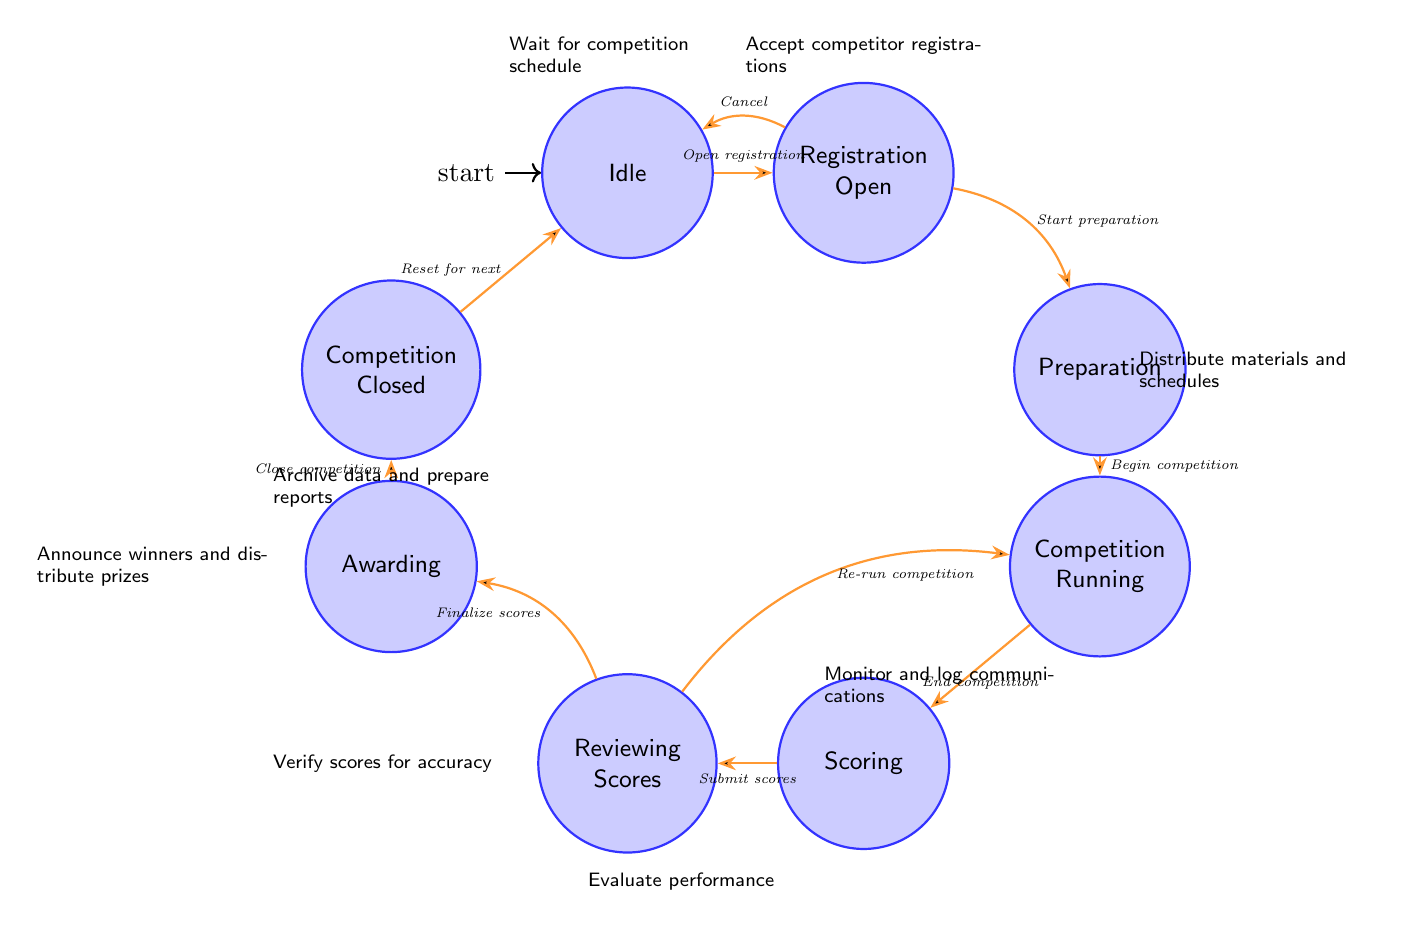What is the initial state of the competition workflow? The initial state is represented by the node labeled "Idle," which indicates that the system is waiting for competition scheduling before moving on.
Answer: Idle How many states are there in total? The diagram lists eight distinct states: Idle, Registration Open, Preparation, Competition Running, Scoring, Reviewing Scores, Awarding, and Competition Closed, which sum up to eight.
Answer: Eight What action follows the state "Scoring"? After the "Scoring" state, the diagram indicates the next state is "Reviewing Scores," as shown by the directed transition arrow leading to it.
Answer: Reviewing Scores What transition happens after "Competition Closed"? The "Competition Closed" state transitions back to "Idle," indicating that the workflow resets after concluding a competition.
Answer: Idle What happens in the "Registration Open" state? In the "Registration Open" state, the workflow involves accepting registrations from competitors as stated in the actions associated with this state.
Answer: Accept competitor registrations What is the final action taken before the competition is closed? The action that takes place right before closing the competition is "Announce winners and distribute prizes," which occurs in the "Awarding" state.
Answer: Announce winners and distribute prizes If a competition is running, what is the next state after scoring? Once scoring is completed in the "Scoring" state, the next state is "Reviewing Scores," where scores are verified for accuracy.
Answer: Reviewing Scores Which state allows for re-running the competition? The "Reviewing Scores" state allows for transitioning back to the "Competition Running" state if scores need to be re-evaluated.
Answer: Competition Running What action is involved when moving from "Preparation" to "Competition Running"? The transition from "Preparation" to "Competition Running" involves the action "Begin competition," indicating the start of the actual competition phase.
Answer: Begin competition 